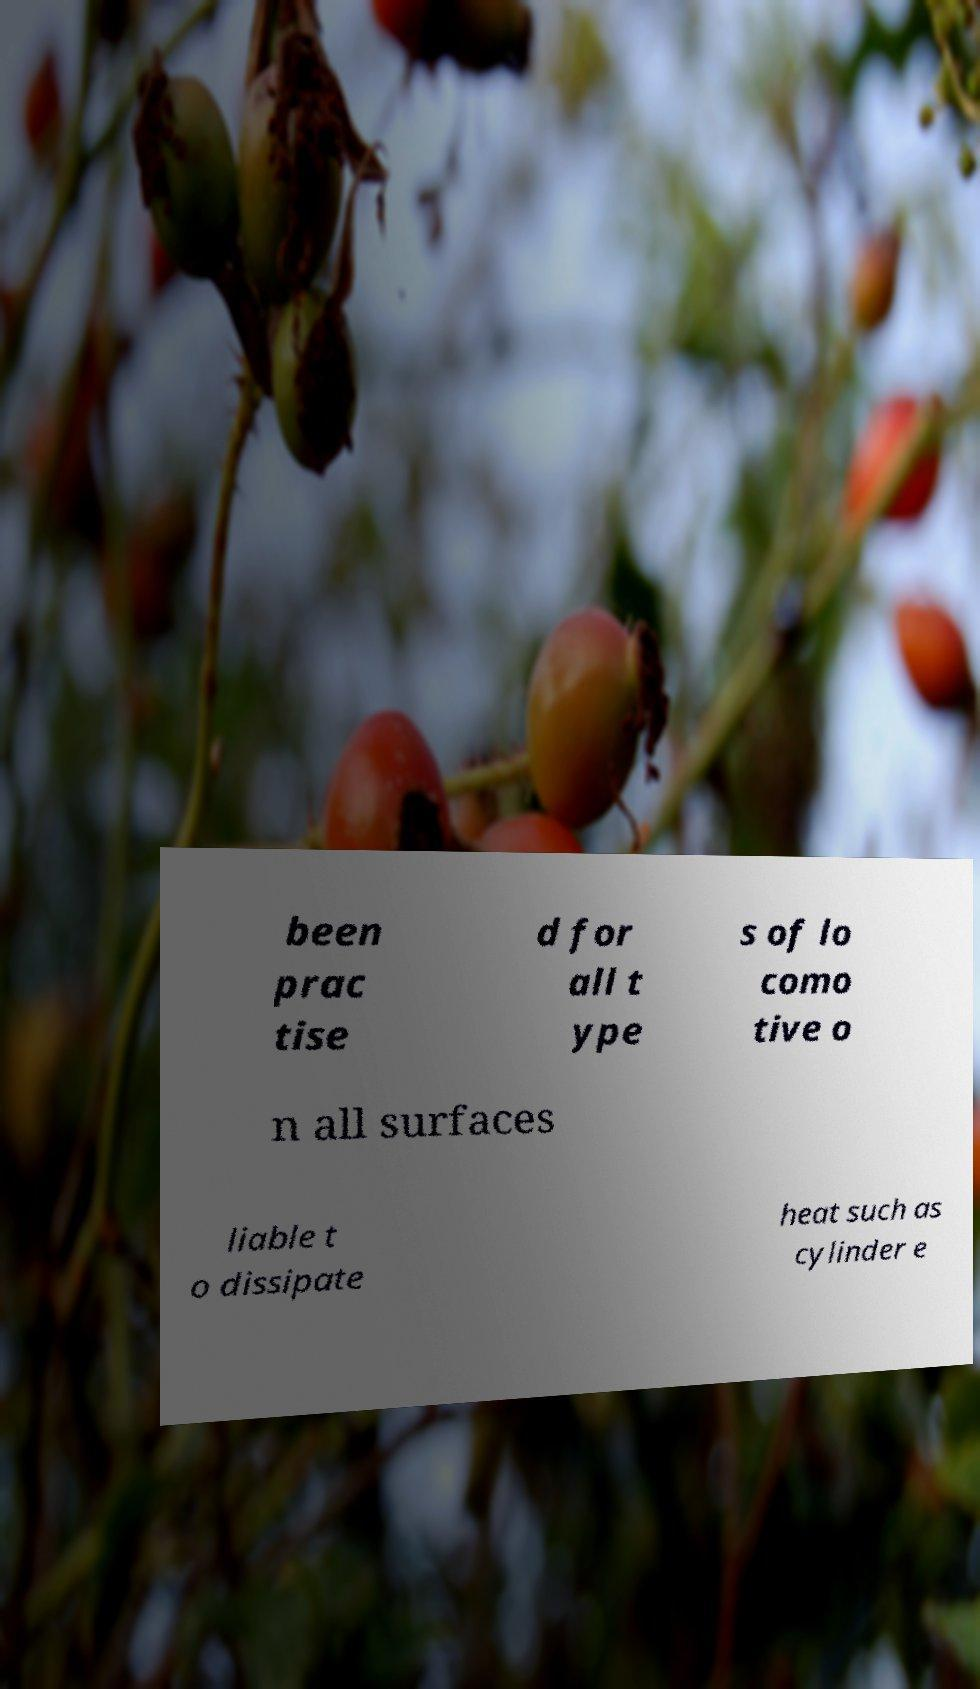There's text embedded in this image that I need extracted. Can you transcribe it verbatim? been prac tise d for all t ype s of lo como tive o n all surfaces liable t o dissipate heat such as cylinder e 